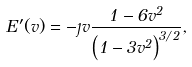<formula> <loc_0><loc_0><loc_500><loc_500>E ^ { \prime } ( v ) = - \eta v \frac { 1 - 6 v ^ { 2 } } { \left ( 1 - 3 v ^ { 2 } \right ) ^ { 3 / 2 } } ,</formula> 